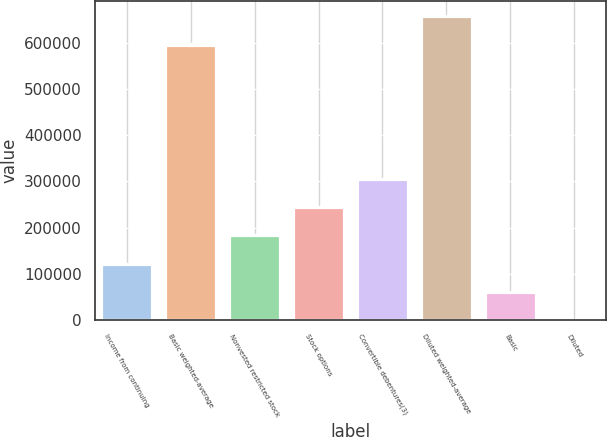<chart> <loc_0><loc_0><loc_500><loc_500><bar_chart><fcel>Income from continuing<fcel>Basic weighted-average<fcel>Nonvested restricted stock<fcel>Stock options<fcel>Convertible debentures(3)<fcel>Diluted weighted-average<fcel>Basic<fcel>Diluted<nl><fcel>121974<fcel>596174<fcel>182961<fcel>243947<fcel>304934<fcel>657160<fcel>60987.8<fcel>1.37<nl></chart> 